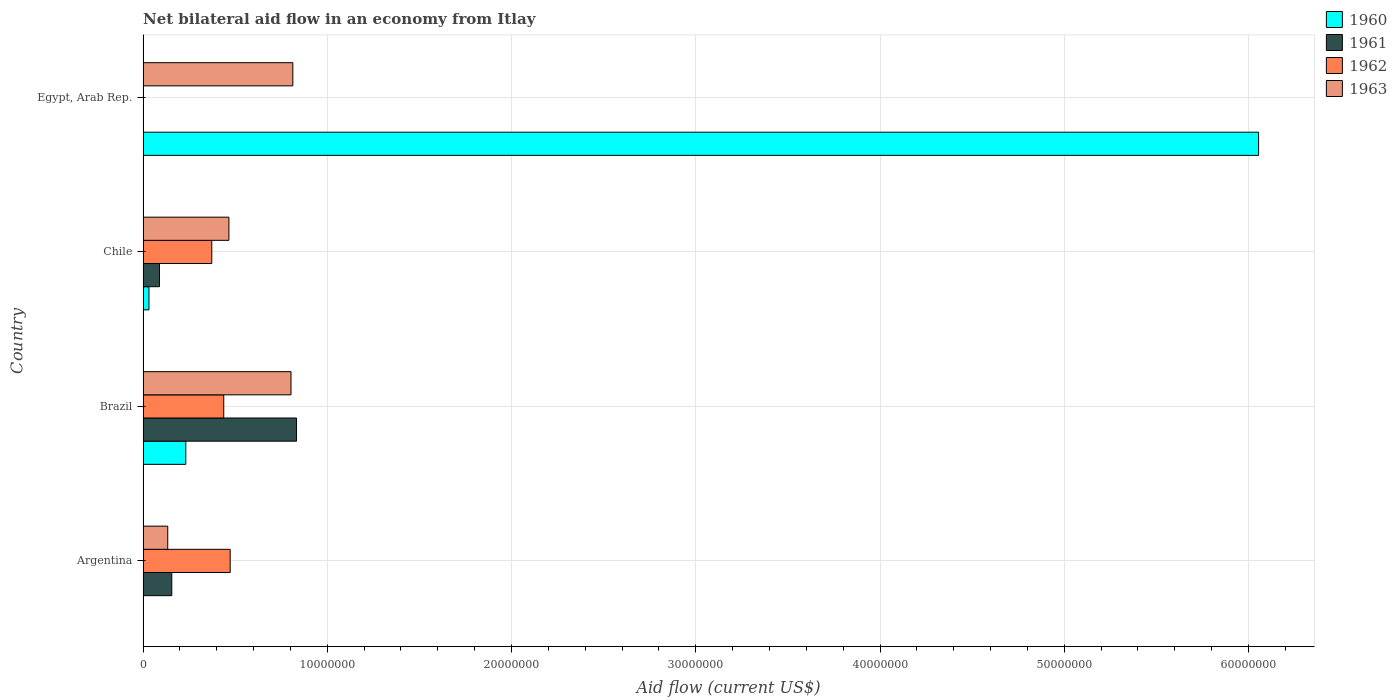How many groups of bars are there?
Ensure brevity in your answer.  4. Are the number of bars on each tick of the Y-axis equal?
Offer a terse response. No. How many bars are there on the 1st tick from the bottom?
Offer a very short reply. 3. What is the label of the 1st group of bars from the top?
Give a very brief answer. Egypt, Arab Rep. What is the net bilateral aid flow in 1963 in Egypt, Arab Rep.?
Provide a succinct answer. 8.13e+06. Across all countries, what is the maximum net bilateral aid flow in 1961?
Give a very brief answer. 8.33e+06. In which country was the net bilateral aid flow in 1961 maximum?
Offer a terse response. Brazil. What is the total net bilateral aid flow in 1961 in the graph?
Your answer should be compact. 1.08e+07. What is the difference between the net bilateral aid flow in 1963 in Brazil and that in Egypt, Arab Rep.?
Provide a succinct answer. -1.00e+05. What is the difference between the net bilateral aid flow in 1961 in Egypt, Arab Rep. and the net bilateral aid flow in 1960 in Argentina?
Ensure brevity in your answer.  0. What is the average net bilateral aid flow in 1962 per country?
Make the answer very short. 3.21e+06. What is the difference between the net bilateral aid flow in 1960 and net bilateral aid flow in 1961 in Chile?
Your response must be concise. -5.70e+05. What is the ratio of the net bilateral aid flow in 1961 in Brazil to that in Chile?
Provide a short and direct response. 9.36. Is the net bilateral aid flow in 1963 in Argentina less than that in Egypt, Arab Rep.?
Ensure brevity in your answer.  Yes. What is the difference between the highest and the second highest net bilateral aid flow in 1960?
Make the answer very short. 5.82e+07. What is the difference between the highest and the lowest net bilateral aid flow in 1963?
Give a very brief answer. 6.79e+06. In how many countries, is the net bilateral aid flow in 1962 greater than the average net bilateral aid flow in 1962 taken over all countries?
Offer a very short reply. 3. Is the sum of the net bilateral aid flow in 1961 in Argentina and Brazil greater than the maximum net bilateral aid flow in 1963 across all countries?
Provide a short and direct response. Yes. Is it the case that in every country, the sum of the net bilateral aid flow in 1961 and net bilateral aid flow in 1963 is greater than the net bilateral aid flow in 1962?
Your response must be concise. No. How many bars are there?
Make the answer very short. 13. Are all the bars in the graph horizontal?
Keep it short and to the point. Yes. How many countries are there in the graph?
Offer a very short reply. 4. What is the difference between two consecutive major ticks on the X-axis?
Give a very brief answer. 1.00e+07. Are the values on the major ticks of X-axis written in scientific E-notation?
Your response must be concise. No. Does the graph contain grids?
Provide a short and direct response. Yes. Where does the legend appear in the graph?
Provide a short and direct response. Top right. How many legend labels are there?
Offer a terse response. 4. What is the title of the graph?
Your answer should be very brief. Net bilateral aid flow in an economy from Itlay. What is the label or title of the X-axis?
Your response must be concise. Aid flow (current US$). What is the Aid flow (current US$) in 1961 in Argentina?
Keep it short and to the point. 1.56e+06. What is the Aid flow (current US$) in 1962 in Argentina?
Provide a short and direct response. 4.73e+06. What is the Aid flow (current US$) of 1963 in Argentina?
Provide a short and direct response. 1.34e+06. What is the Aid flow (current US$) of 1960 in Brazil?
Keep it short and to the point. 2.32e+06. What is the Aid flow (current US$) of 1961 in Brazil?
Offer a very short reply. 8.33e+06. What is the Aid flow (current US$) of 1962 in Brazil?
Provide a short and direct response. 4.38e+06. What is the Aid flow (current US$) in 1963 in Brazil?
Make the answer very short. 8.03e+06. What is the Aid flow (current US$) in 1960 in Chile?
Provide a short and direct response. 3.20e+05. What is the Aid flow (current US$) of 1961 in Chile?
Offer a very short reply. 8.90e+05. What is the Aid flow (current US$) of 1962 in Chile?
Offer a very short reply. 3.73e+06. What is the Aid flow (current US$) of 1963 in Chile?
Make the answer very short. 4.66e+06. What is the Aid flow (current US$) in 1960 in Egypt, Arab Rep.?
Give a very brief answer. 6.06e+07. What is the Aid flow (current US$) in 1962 in Egypt, Arab Rep.?
Your answer should be very brief. 0. What is the Aid flow (current US$) of 1963 in Egypt, Arab Rep.?
Give a very brief answer. 8.13e+06. Across all countries, what is the maximum Aid flow (current US$) of 1960?
Provide a short and direct response. 6.06e+07. Across all countries, what is the maximum Aid flow (current US$) in 1961?
Ensure brevity in your answer.  8.33e+06. Across all countries, what is the maximum Aid flow (current US$) in 1962?
Offer a terse response. 4.73e+06. Across all countries, what is the maximum Aid flow (current US$) in 1963?
Your answer should be compact. 8.13e+06. Across all countries, what is the minimum Aid flow (current US$) in 1960?
Offer a terse response. 0. Across all countries, what is the minimum Aid flow (current US$) in 1961?
Offer a terse response. 0. Across all countries, what is the minimum Aid flow (current US$) in 1962?
Your answer should be very brief. 0. Across all countries, what is the minimum Aid flow (current US$) of 1963?
Offer a very short reply. 1.34e+06. What is the total Aid flow (current US$) in 1960 in the graph?
Ensure brevity in your answer.  6.32e+07. What is the total Aid flow (current US$) of 1961 in the graph?
Provide a succinct answer. 1.08e+07. What is the total Aid flow (current US$) in 1962 in the graph?
Offer a very short reply. 1.28e+07. What is the total Aid flow (current US$) in 1963 in the graph?
Provide a succinct answer. 2.22e+07. What is the difference between the Aid flow (current US$) of 1961 in Argentina and that in Brazil?
Your answer should be compact. -6.77e+06. What is the difference between the Aid flow (current US$) of 1963 in Argentina and that in Brazil?
Provide a succinct answer. -6.69e+06. What is the difference between the Aid flow (current US$) of 1961 in Argentina and that in Chile?
Keep it short and to the point. 6.70e+05. What is the difference between the Aid flow (current US$) of 1963 in Argentina and that in Chile?
Your response must be concise. -3.32e+06. What is the difference between the Aid flow (current US$) of 1963 in Argentina and that in Egypt, Arab Rep.?
Offer a terse response. -6.79e+06. What is the difference between the Aid flow (current US$) in 1960 in Brazil and that in Chile?
Provide a succinct answer. 2.00e+06. What is the difference between the Aid flow (current US$) of 1961 in Brazil and that in Chile?
Your answer should be compact. 7.44e+06. What is the difference between the Aid flow (current US$) of 1962 in Brazil and that in Chile?
Ensure brevity in your answer.  6.50e+05. What is the difference between the Aid flow (current US$) in 1963 in Brazil and that in Chile?
Ensure brevity in your answer.  3.37e+06. What is the difference between the Aid flow (current US$) of 1960 in Brazil and that in Egypt, Arab Rep.?
Your answer should be very brief. -5.82e+07. What is the difference between the Aid flow (current US$) of 1960 in Chile and that in Egypt, Arab Rep.?
Offer a very short reply. -6.02e+07. What is the difference between the Aid flow (current US$) in 1963 in Chile and that in Egypt, Arab Rep.?
Ensure brevity in your answer.  -3.47e+06. What is the difference between the Aid flow (current US$) in 1961 in Argentina and the Aid flow (current US$) in 1962 in Brazil?
Your answer should be very brief. -2.82e+06. What is the difference between the Aid flow (current US$) of 1961 in Argentina and the Aid flow (current US$) of 1963 in Brazil?
Ensure brevity in your answer.  -6.47e+06. What is the difference between the Aid flow (current US$) of 1962 in Argentina and the Aid flow (current US$) of 1963 in Brazil?
Provide a succinct answer. -3.30e+06. What is the difference between the Aid flow (current US$) in 1961 in Argentina and the Aid flow (current US$) in 1962 in Chile?
Ensure brevity in your answer.  -2.17e+06. What is the difference between the Aid flow (current US$) of 1961 in Argentina and the Aid flow (current US$) of 1963 in Chile?
Keep it short and to the point. -3.10e+06. What is the difference between the Aid flow (current US$) in 1962 in Argentina and the Aid flow (current US$) in 1963 in Chile?
Your response must be concise. 7.00e+04. What is the difference between the Aid flow (current US$) of 1961 in Argentina and the Aid flow (current US$) of 1963 in Egypt, Arab Rep.?
Keep it short and to the point. -6.57e+06. What is the difference between the Aid flow (current US$) in 1962 in Argentina and the Aid flow (current US$) in 1963 in Egypt, Arab Rep.?
Provide a succinct answer. -3.40e+06. What is the difference between the Aid flow (current US$) of 1960 in Brazil and the Aid flow (current US$) of 1961 in Chile?
Offer a terse response. 1.43e+06. What is the difference between the Aid flow (current US$) in 1960 in Brazil and the Aid flow (current US$) in 1962 in Chile?
Provide a succinct answer. -1.41e+06. What is the difference between the Aid flow (current US$) in 1960 in Brazil and the Aid flow (current US$) in 1963 in Chile?
Offer a terse response. -2.34e+06. What is the difference between the Aid flow (current US$) in 1961 in Brazil and the Aid flow (current US$) in 1962 in Chile?
Offer a terse response. 4.60e+06. What is the difference between the Aid flow (current US$) of 1961 in Brazil and the Aid flow (current US$) of 1963 in Chile?
Keep it short and to the point. 3.67e+06. What is the difference between the Aid flow (current US$) of 1962 in Brazil and the Aid flow (current US$) of 1963 in Chile?
Make the answer very short. -2.80e+05. What is the difference between the Aid flow (current US$) of 1960 in Brazil and the Aid flow (current US$) of 1963 in Egypt, Arab Rep.?
Give a very brief answer. -5.81e+06. What is the difference between the Aid flow (current US$) in 1961 in Brazil and the Aid flow (current US$) in 1963 in Egypt, Arab Rep.?
Ensure brevity in your answer.  2.00e+05. What is the difference between the Aid flow (current US$) of 1962 in Brazil and the Aid flow (current US$) of 1963 in Egypt, Arab Rep.?
Your answer should be very brief. -3.75e+06. What is the difference between the Aid flow (current US$) of 1960 in Chile and the Aid flow (current US$) of 1963 in Egypt, Arab Rep.?
Keep it short and to the point. -7.81e+06. What is the difference between the Aid flow (current US$) of 1961 in Chile and the Aid flow (current US$) of 1963 in Egypt, Arab Rep.?
Provide a succinct answer. -7.24e+06. What is the difference between the Aid flow (current US$) of 1962 in Chile and the Aid flow (current US$) of 1963 in Egypt, Arab Rep.?
Your response must be concise. -4.40e+06. What is the average Aid flow (current US$) of 1960 per country?
Keep it short and to the point. 1.58e+07. What is the average Aid flow (current US$) of 1961 per country?
Ensure brevity in your answer.  2.70e+06. What is the average Aid flow (current US$) in 1962 per country?
Provide a succinct answer. 3.21e+06. What is the average Aid flow (current US$) in 1963 per country?
Offer a terse response. 5.54e+06. What is the difference between the Aid flow (current US$) in 1961 and Aid flow (current US$) in 1962 in Argentina?
Your answer should be very brief. -3.17e+06. What is the difference between the Aid flow (current US$) of 1962 and Aid flow (current US$) of 1963 in Argentina?
Give a very brief answer. 3.39e+06. What is the difference between the Aid flow (current US$) of 1960 and Aid flow (current US$) of 1961 in Brazil?
Your response must be concise. -6.01e+06. What is the difference between the Aid flow (current US$) in 1960 and Aid flow (current US$) in 1962 in Brazil?
Your answer should be very brief. -2.06e+06. What is the difference between the Aid flow (current US$) in 1960 and Aid flow (current US$) in 1963 in Brazil?
Your answer should be very brief. -5.71e+06. What is the difference between the Aid flow (current US$) of 1961 and Aid flow (current US$) of 1962 in Brazil?
Your answer should be very brief. 3.95e+06. What is the difference between the Aid flow (current US$) of 1961 and Aid flow (current US$) of 1963 in Brazil?
Offer a terse response. 3.00e+05. What is the difference between the Aid flow (current US$) of 1962 and Aid flow (current US$) of 1963 in Brazil?
Offer a very short reply. -3.65e+06. What is the difference between the Aid flow (current US$) of 1960 and Aid flow (current US$) of 1961 in Chile?
Offer a terse response. -5.70e+05. What is the difference between the Aid flow (current US$) in 1960 and Aid flow (current US$) in 1962 in Chile?
Your answer should be compact. -3.41e+06. What is the difference between the Aid flow (current US$) of 1960 and Aid flow (current US$) of 1963 in Chile?
Your answer should be compact. -4.34e+06. What is the difference between the Aid flow (current US$) of 1961 and Aid flow (current US$) of 1962 in Chile?
Your answer should be very brief. -2.84e+06. What is the difference between the Aid flow (current US$) in 1961 and Aid flow (current US$) in 1963 in Chile?
Provide a short and direct response. -3.77e+06. What is the difference between the Aid flow (current US$) of 1962 and Aid flow (current US$) of 1963 in Chile?
Your response must be concise. -9.30e+05. What is the difference between the Aid flow (current US$) of 1960 and Aid flow (current US$) of 1963 in Egypt, Arab Rep.?
Provide a succinct answer. 5.24e+07. What is the ratio of the Aid flow (current US$) in 1961 in Argentina to that in Brazil?
Make the answer very short. 0.19. What is the ratio of the Aid flow (current US$) in 1962 in Argentina to that in Brazil?
Your answer should be very brief. 1.08. What is the ratio of the Aid flow (current US$) of 1963 in Argentina to that in Brazil?
Make the answer very short. 0.17. What is the ratio of the Aid flow (current US$) in 1961 in Argentina to that in Chile?
Your answer should be very brief. 1.75. What is the ratio of the Aid flow (current US$) in 1962 in Argentina to that in Chile?
Give a very brief answer. 1.27. What is the ratio of the Aid flow (current US$) of 1963 in Argentina to that in Chile?
Offer a very short reply. 0.29. What is the ratio of the Aid flow (current US$) in 1963 in Argentina to that in Egypt, Arab Rep.?
Your answer should be very brief. 0.16. What is the ratio of the Aid flow (current US$) of 1960 in Brazil to that in Chile?
Your answer should be compact. 7.25. What is the ratio of the Aid flow (current US$) in 1961 in Brazil to that in Chile?
Your response must be concise. 9.36. What is the ratio of the Aid flow (current US$) of 1962 in Brazil to that in Chile?
Make the answer very short. 1.17. What is the ratio of the Aid flow (current US$) in 1963 in Brazil to that in Chile?
Provide a succinct answer. 1.72. What is the ratio of the Aid flow (current US$) in 1960 in Brazil to that in Egypt, Arab Rep.?
Provide a succinct answer. 0.04. What is the ratio of the Aid flow (current US$) of 1963 in Brazil to that in Egypt, Arab Rep.?
Make the answer very short. 0.99. What is the ratio of the Aid flow (current US$) of 1960 in Chile to that in Egypt, Arab Rep.?
Ensure brevity in your answer.  0.01. What is the ratio of the Aid flow (current US$) of 1963 in Chile to that in Egypt, Arab Rep.?
Make the answer very short. 0.57. What is the difference between the highest and the second highest Aid flow (current US$) of 1960?
Offer a terse response. 5.82e+07. What is the difference between the highest and the second highest Aid flow (current US$) of 1961?
Offer a terse response. 6.77e+06. What is the difference between the highest and the lowest Aid flow (current US$) of 1960?
Provide a succinct answer. 6.06e+07. What is the difference between the highest and the lowest Aid flow (current US$) in 1961?
Offer a terse response. 8.33e+06. What is the difference between the highest and the lowest Aid flow (current US$) of 1962?
Offer a terse response. 4.73e+06. What is the difference between the highest and the lowest Aid flow (current US$) of 1963?
Your answer should be compact. 6.79e+06. 